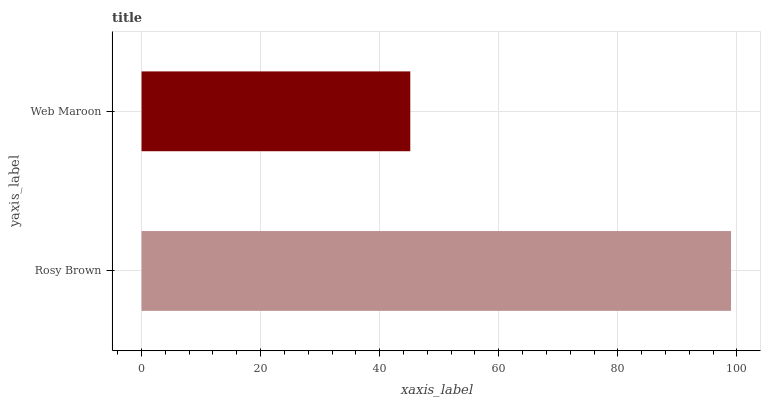Is Web Maroon the minimum?
Answer yes or no. Yes. Is Rosy Brown the maximum?
Answer yes or no. Yes. Is Web Maroon the maximum?
Answer yes or no. No. Is Rosy Brown greater than Web Maroon?
Answer yes or no. Yes. Is Web Maroon less than Rosy Brown?
Answer yes or no. Yes. Is Web Maroon greater than Rosy Brown?
Answer yes or no. No. Is Rosy Brown less than Web Maroon?
Answer yes or no. No. Is Rosy Brown the high median?
Answer yes or no. Yes. Is Web Maroon the low median?
Answer yes or no. Yes. Is Web Maroon the high median?
Answer yes or no. No. Is Rosy Brown the low median?
Answer yes or no. No. 